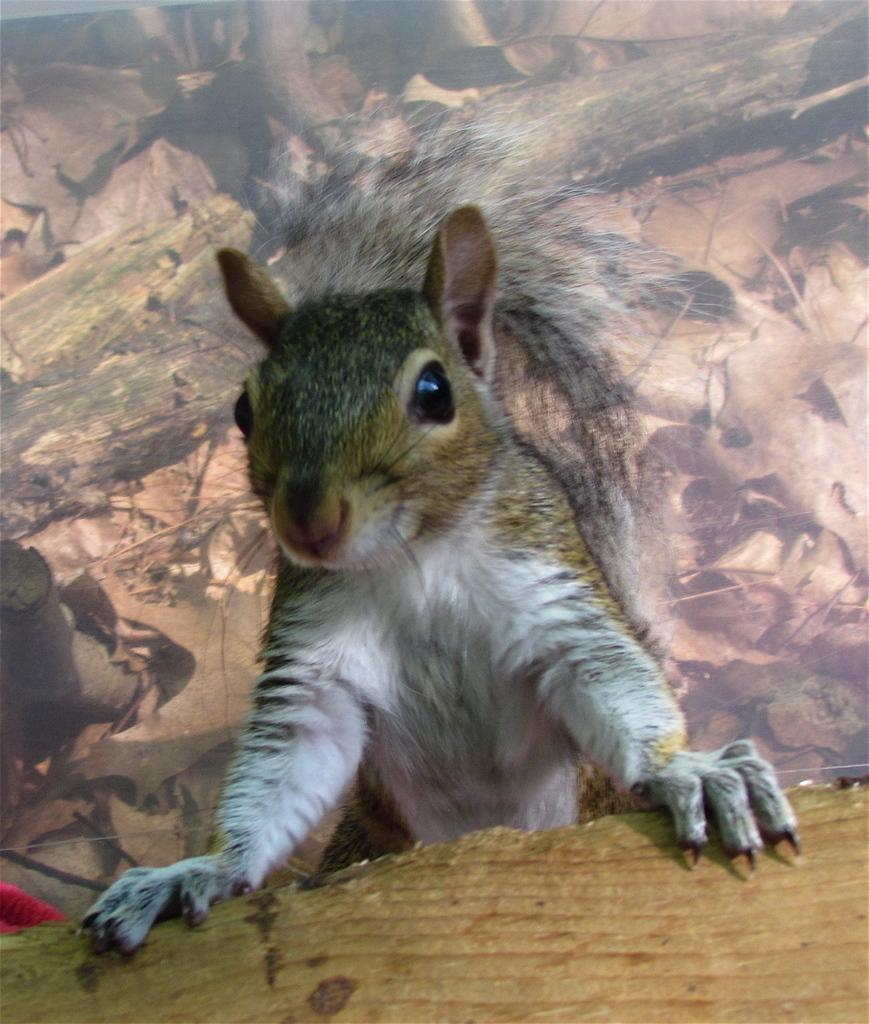What is the main subject in the center of the image? There is a squirrel in the center of the image. What can be seen in the background of the image? There is a painting on the wall in the background of the image. What type of music is the squirrel playing in the image? There is no music or musical instrument present in the image, so it cannot be determined what type of music the squirrel might be playing. 